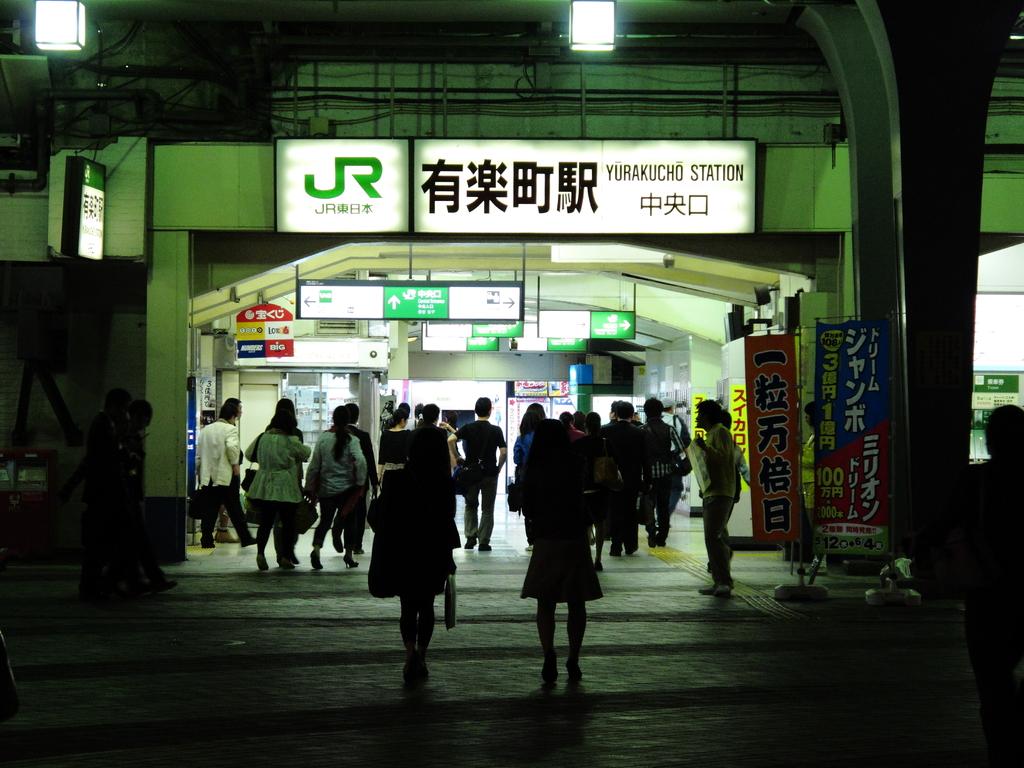What is the name of the station on the sign?
Your response must be concise. Yurakucho. What does the sign outside the complex state?
Your answer should be very brief. Yurakucho station. 